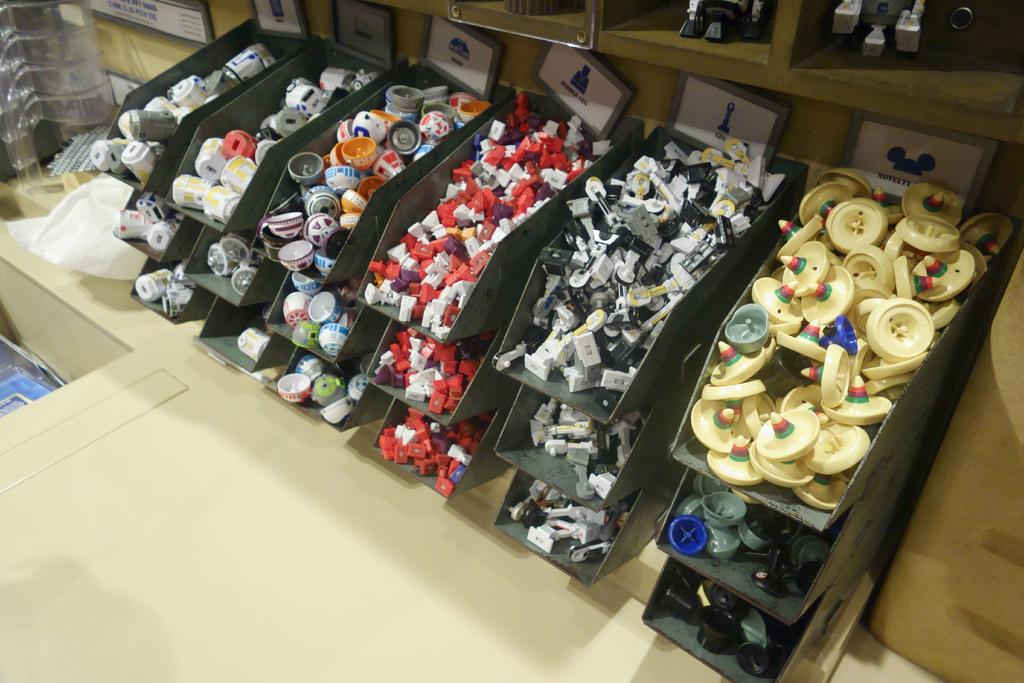What can be seen on the shelves in the image? There are objects placed on shelves in the image. Can you describe the arrangement of the objects on the shelves? Unfortunately, the provided facts do not give enough information to describe the arrangement of the objects on the shelves. What type of objects might be found on shelves in general? Objects on shelves can vary widely, but they might include books, decorative items, or household items. What is the taste of the bomb in the image? There is no bomb present in the image, so it is not possible to determine its taste. 